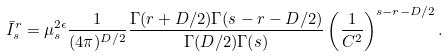Convert formula to latex. <formula><loc_0><loc_0><loc_500><loc_500>\bar { I } ^ { r } _ { s } = \mu ^ { 2 \epsilon } _ { s } \frac { 1 } { ( 4 \pi ) ^ { D / 2 } } \frac { \Gamma ( r + D / 2 ) \Gamma ( s - r - D / 2 ) } { \Gamma ( D / 2 ) \Gamma ( s ) } \left ( \frac { 1 } { C ^ { 2 } } \right ) ^ { s - r - D / 2 } .</formula> 